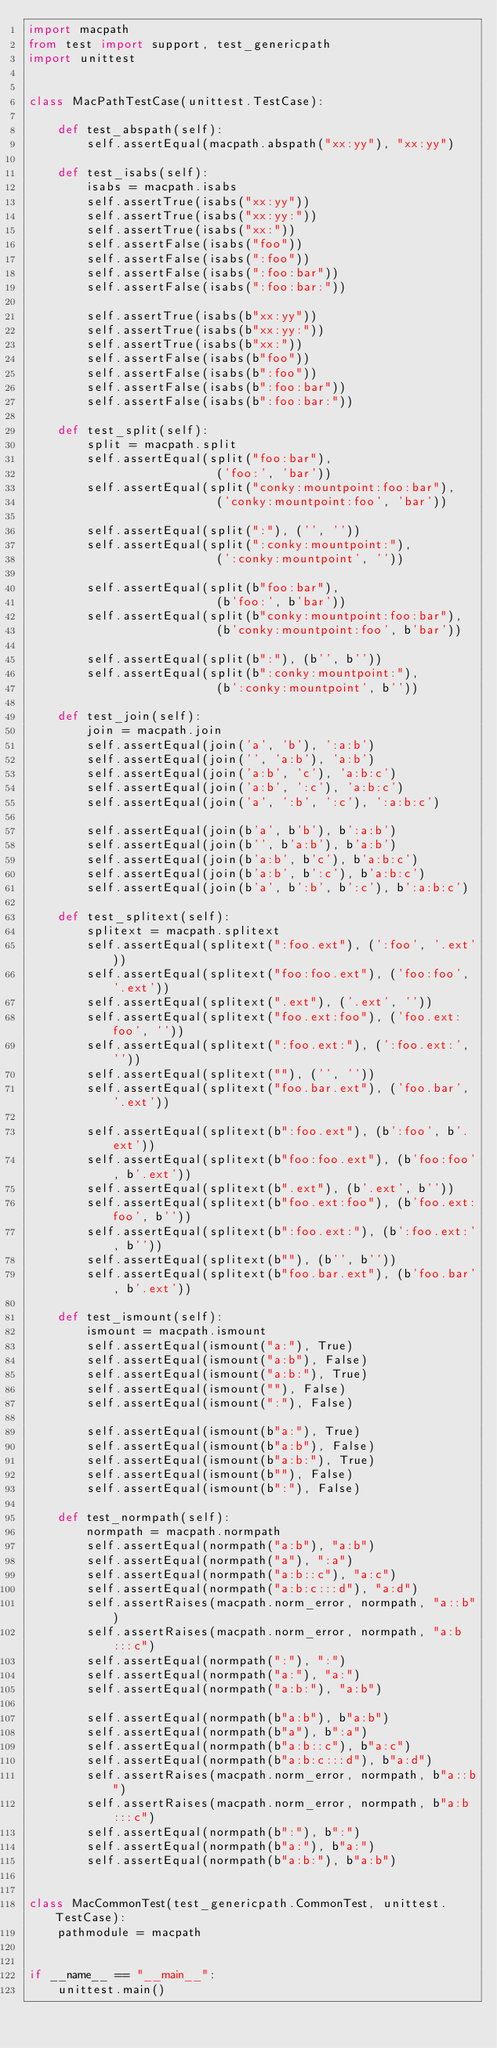Convert code to text. <code><loc_0><loc_0><loc_500><loc_500><_Python_>import macpath
from test import support, test_genericpath
import unittest


class MacPathTestCase(unittest.TestCase):

    def test_abspath(self):
        self.assertEqual(macpath.abspath("xx:yy"), "xx:yy")

    def test_isabs(self):
        isabs = macpath.isabs
        self.assertTrue(isabs("xx:yy"))
        self.assertTrue(isabs("xx:yy:"))
        self.assertTrue(isabs("xx:"))
        self.assertFalse(isabs("foo"))
        self.assertFalse(isabs(":foo"))
        self.assertFalse(isabs(":foo:bar"))
        self.assertFalse(isabs(":foo:bar:"))

        self.assertTrue(isabs(b"xx:yy"))
        self.assertTrue(isabs(b"xx:yy:"))
        self.assertTrue(isabs(b"xx:"))
        self.assertFalse(isabs(b"foo"))
        self.assertFalse(isabs(b":foo"))
        self.assertFalse(isabs(b":foo:bar"))
        self.assertFalse(isabs(b":foo:bar:"))

    def test_split(self):
        split = macpath.split
        self.assertEqual(split("foo:bar"),
                          ('foo:', 'bar'))
        self.assertEqual(split("conky:mountpoint:foo:bar"),
                          ('conky:mountpoint:foo', 'bar'))

        self.assertEqual(split(":"), ('', ''))
        self.assertEqual(split(":conky:mountpoint:"),
                          (':conky:mountpoint', ''))

        self.assertEqual(split(b"foo:bar"),
                          (b'foo:', b'bar'))
        self.assertEqual(split(b"conky:mountpoint:foo:bar"),
                          (b'conky:mountpoint:foo', b'bar'))

        self.assertEqual(split(b":"), (b'', b''))
        self.assertEqual(split(b":conky:mountpoint:"),
                          (b':conky:mountpoint', b''))

    def test_join(self):
        join = macpath.join
        self.assertEqual(join('a', 'b'), ':a:b')
        self.assertEqual(join('', 'a:b'), 'a:b')
        self.assertEqual(join('a:b', 'c'), 'a:b:c')
        self.assertEqual(join('a:b', ':c'), 'a:b:c')
        self.assertEqual(join('a', ':b', ':c'), ':a:b:c')

        self.assertEqual(join(b'a', b'b'), b':a:b')
        self.assertEqual(join(b'', b'a:b'), b'a:b')
        self.assertEqual(join(b'a:b', b'c'), b'a:b:c')
        self.assertEqual(join(b'a:b', b':c'), b'a:b:c')
        self.assertEqual(join(b'a', b':b', b':c'), b':a:b:c')

    def test_splitext(self):
        splitext = macpath.splitext
        self.assertEqual(splitext(":foo.ext"), (':foo', '.ext'))
        self.assertEqual(splitext("foo:foo.ext"), ('foo:foo', '.ext'))
        self.assertEqual(splitext(".ext"), ('.ext', ''))
        self.assertEqual(splitext("foo.ext:foo"), ('foo.ext:foo', ''))
        self.assertEqual(splitext(":foo.ext:"), (':foo.ext:', ''))
        self.assertEqual(splitext(""), ('', ''))
        self.assertEqual(splitext("foo.bar.ext"), ('foo.bar', '.ext'))

        self.assertEqual(splitext(b":foo.ext"), (b':foo', b'.ext'))
        self.assertEqual(splitext(b"foo:foo.ext"), (b'foo:foo', b'.ext'))
        self.assertEqual(splitext(b".ext"), (b'.ext', b''))
        self.assertEqual(splitext(b"foo.ext:foo"), (b'foo.ext:foo', b''))
        self.assertEqual(splitext(b":foo.ext:"), (b':foo.ext:', b''))
        self.assertEqual(splitext(b""), (b'', b''))
        self.assertEqual(splitext(b"foo.bar.ext"), (b'foo.bar', b'.ext'))

    def test_ismount(self):
        ismount = macpath.ismount
        self.assertEqual(ismount("a:"), True)
        self.assertEqual(ismount("a:b"), False)
        self.assertEqual(ismount("a:b:"), True)
        self.assertEqual(ismount(""), False)
        self.assertEqual(ismount(":"), False)

        self.assertEqual(ismount(b"a:"), True)
        self.assertEqual(ismount(b"a:b"), False)
        self.assertEqual(ismount(b"a:b:"), True)
        self.assertEqual(ismount(b""), False)
        self.assertEqual(ismount(b":"), False)

    def test_normpath(self):
        normpath = macpath.normpath
        self.assertEqual(normpath("a:b"), "a:b")
        self.assertEqual(normpath("a"), ":a")
        self.assertEqual(normpath("a:b::c"), "a:c")
        self.assertEqual(normpath("a:b:c:::d"), "a:d")
        self.assertRaises(macpath.norm_error, normpath, "a::b")
        self.assertRaises(macpath.norm_error, normpath, "a:b:::c")
        self.assertEqual(normpath(":"), ":")
        self.assertEqual(normpath("a:"), "a:")
        self.assertEqual(normpath("a:b:"), "a:b")

        self.assertEqual(normpath(b"a:b"), b"a:b")
        self.assertEqual(normpath(b"a"), b":a")
        self.assertEqual(normpath(b"a:b::c"), b"a:c")
        self.assertEqual(normpath(b"a:b:c:::d"), b"a:d")
        self.assertRaises(macpath.norm_error, normpath, b"a::b")
        self.assertRaises(macpath.norm_error, normpath, b"a:b:::c")
        self.assertEqual(normpath(b":"), b":")
        self.assertEqual(normpath(b"a:"), b"a:")
        self.assertEqual(normpath(b"a:b:"), b"a:b")


class MacCommonTest(test_genericpath.CommonTest, unittest.TestCase):
    pathmodule = macpath


if __name__ == "__main__":
    unittest.main()
</code> 